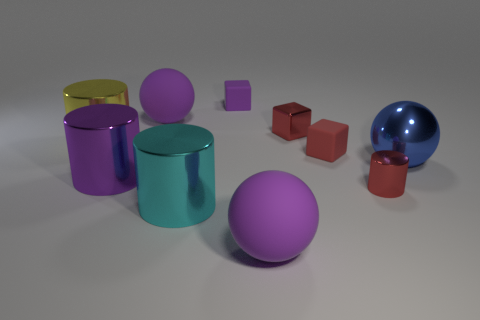Subtract 1 cylinders. How many cylinders are left? 3 Subtract all cubes. How many objects are left? 7 Add 2 large metal spheres. How many large metal spheres are left? 3 Add 5 large purple metallic cylinders. How many large purple metallic cylinders exist? 6 Subtract 0 yellow balls. How many objects are left? 10 Subtract all red objects. Subtract all red things. How many objects are left? 4 